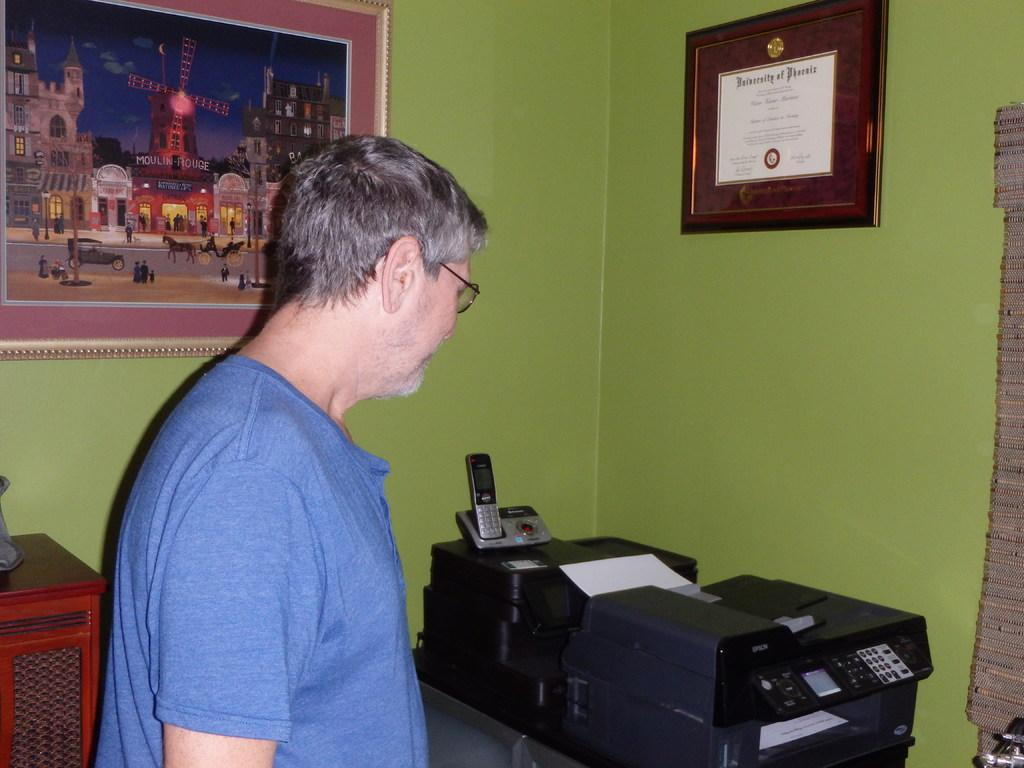<image>
Present a compact description of the photo's key features. a man is in a room with a diploma from the University of Phoenix 